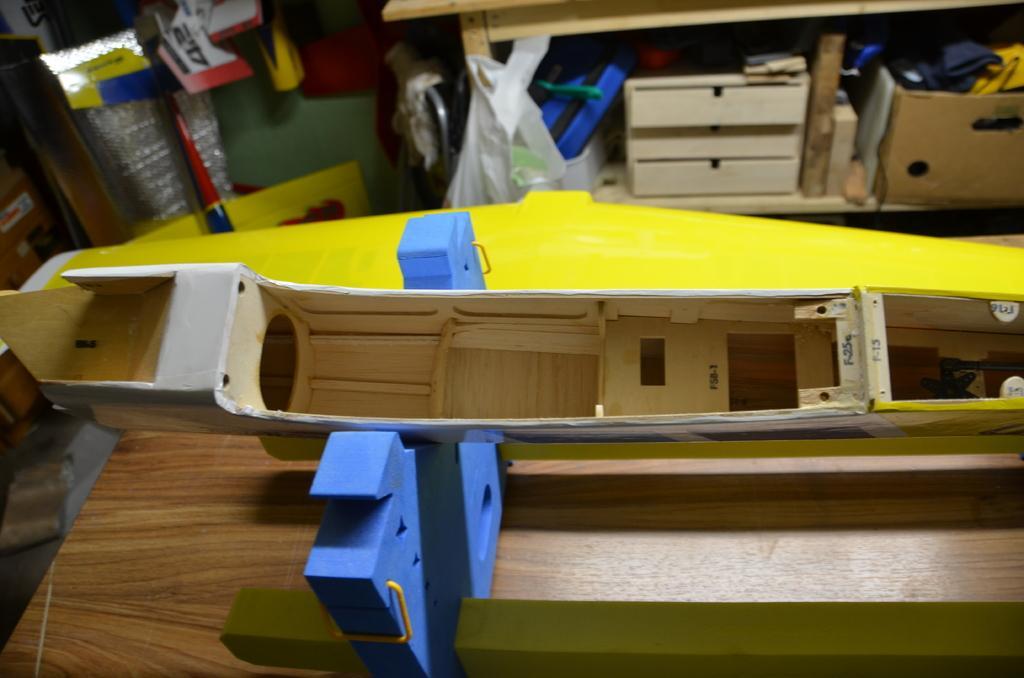Can you describe this image briefly? In this image I can see wooden objects on the table. In the background I can see a table, cartoon box, clothes, wall and so on. This image is taken may be in a room. 